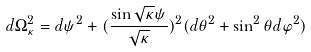<formula> <loc_0><loc_0><loc_500><loc_500>d \Omega _ { \kappa } ^ { 2 } = d \psi ^ { 2 } + ( \frac { \sin \sqrt { \kappa } \psi } { \sqrt { \kappa } } ) ^ { 2 } ( d \theta ^ { 2 } + \sin ^ { 2 } \theta d \varphi ^ { 2 } )</formula> 